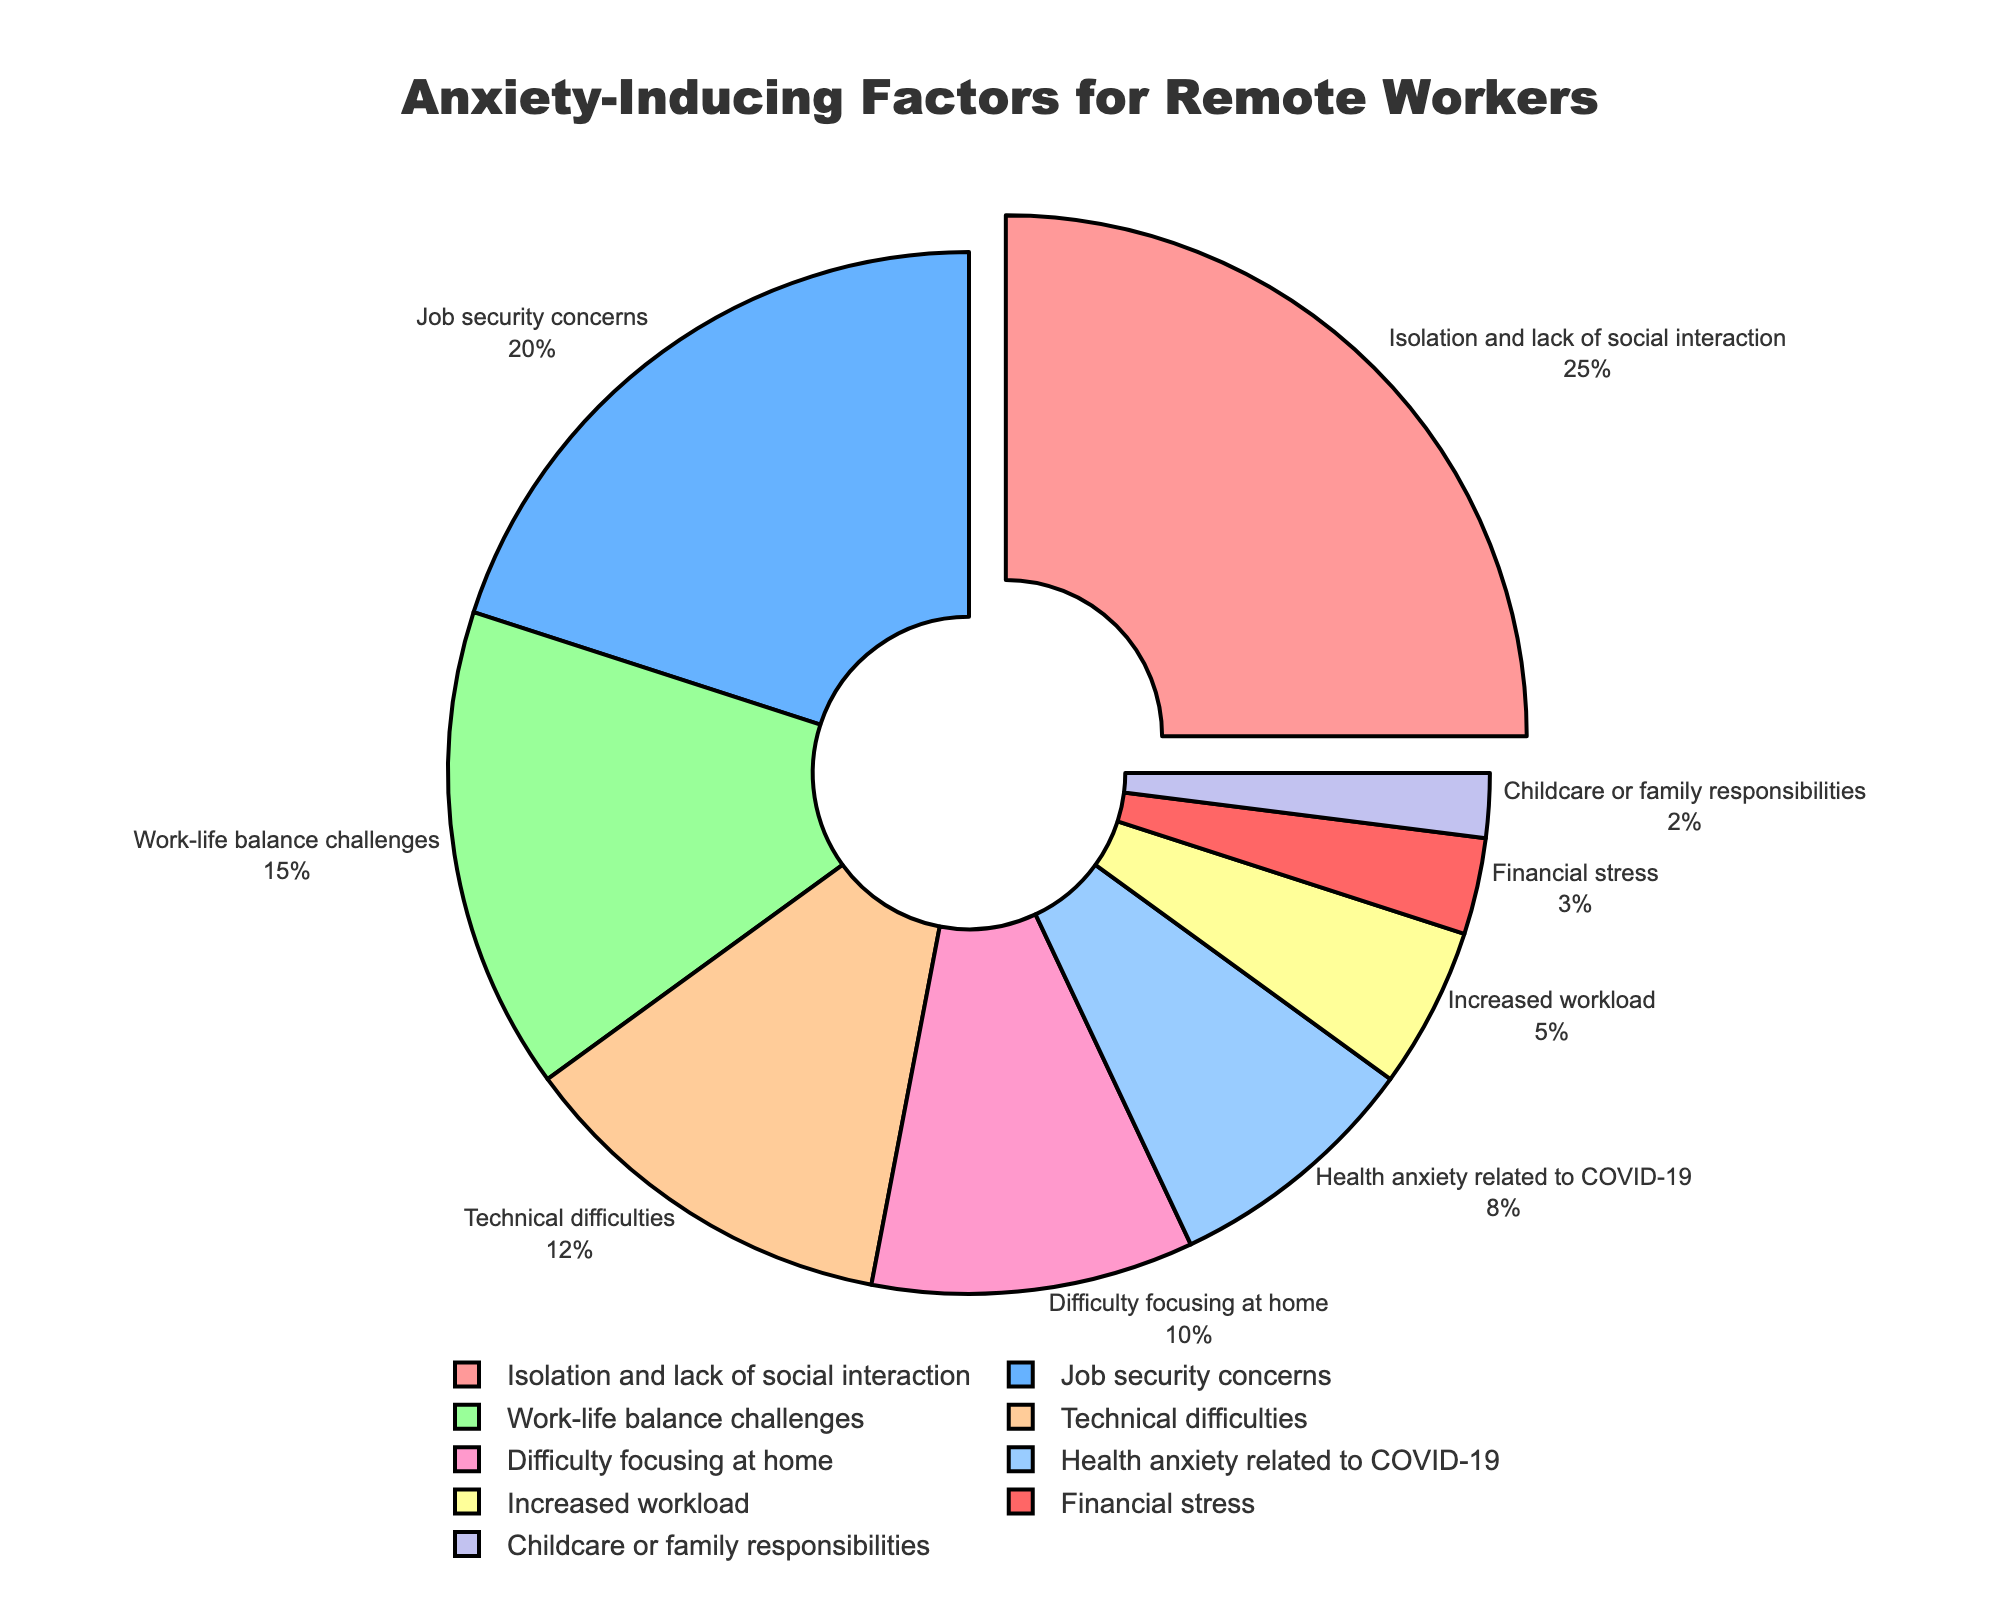Which anxiety-inducing factor is the most significant for remote workers during the pandemic? According to the pie chart, look for the largest slice. The "Isolation and lack of social interaction" factor occupies the largest portion of the pie chart.
Answer: Isolation and lack of social interaction How much more significant is "Job security concerns" compared to "Increased workload"? Find the percentages of both factors in the pie chart. "Job security concerns" are at 20% and "Increased workload" is at 5%. Subtract the smaller percentage from the larger one: 20% - 5% = 15%.
Answer: 15% What percentage of the anxiety factors is related to "Technical difficulties" and "Difficulty focusing at home" combined? Add the percentages of "Technical difficulties" (12%) and "Difficulty focusing at home" (10%). 12% + 10% = 22%.
Answer: 22% Which factors have a percentage less than 10%? Identify all slices in the pie chart with percentages below 10%. These are "Health anxiety related to COVID-19" (8%), "Increased workload" (5%), "Financial stress" (3%), and "Childcare or family responsibilities" (2%).
Answer: Health anxiety related to COVID-19, Increased workload, Financial stress, Childcare or family responsibilities What are the two smallest anxiety-inducing factors for remote workers according to the chart? Observe the pie chart for the smallest slices. The two smallest factors are "Childcare or family responsibilities" (2%) and "Financial stress" (3%).
Answer: Childcare or family responsibilities, Financial stress What is the difference in the percentage between the most and least significant anxiety-inducing factor? Determine the percentages for the largest and smallest slices. The largest is "Isolation and lack of social interaction" at 25% and the smallest is "Childcare or family responsibilities" at 2%. Subtract the smaller percentage from the larger one: 25% - 2% = 23%.
Answer: 23% What is the average percentage of the top three anxiety-inducing factors? Identify the top three factors by their percentages: "Isolation and lack of social interaction" (25%), "Job security concerns" (20%), and "Work-life balance challenges" (15%). Calculate the average: (25% + 20% + 15%) / 3 = 20%.
Answer: 20% Is the percentage of "Work-life balance challenges" greater than "Health anxiety related to COVID-19" and "Increased workload" combined? "Work-life balance challenges" are at 15%. "Health anxiety related to COVID-19" is 8% and "Increased workload" is 5%. Add the two smaller percentages: 8% + 5% = 13%. 15% is greater than 13%.
Answer: Yes What is the combined percentage of all factors that are above 10%? Factors above 10% are "Isolation and lack of social interaction" (25%), "Job security concerns" (20%), "Work-life balance challenges" (15%), and "Technical difficulties" (12%). Add these percentages together: 25% + 20% + 15% + 12% = 72%.
Answer: 72% How does the percentage of "Financial stress" compare to "Childcare or family responsibilities"? "Financial stress" is at 3% and "Childcare or family responsibilities" is at 2%. "Financial stress" is 1% more than "Childcare or family responsibilities".
Answer: 1% more 